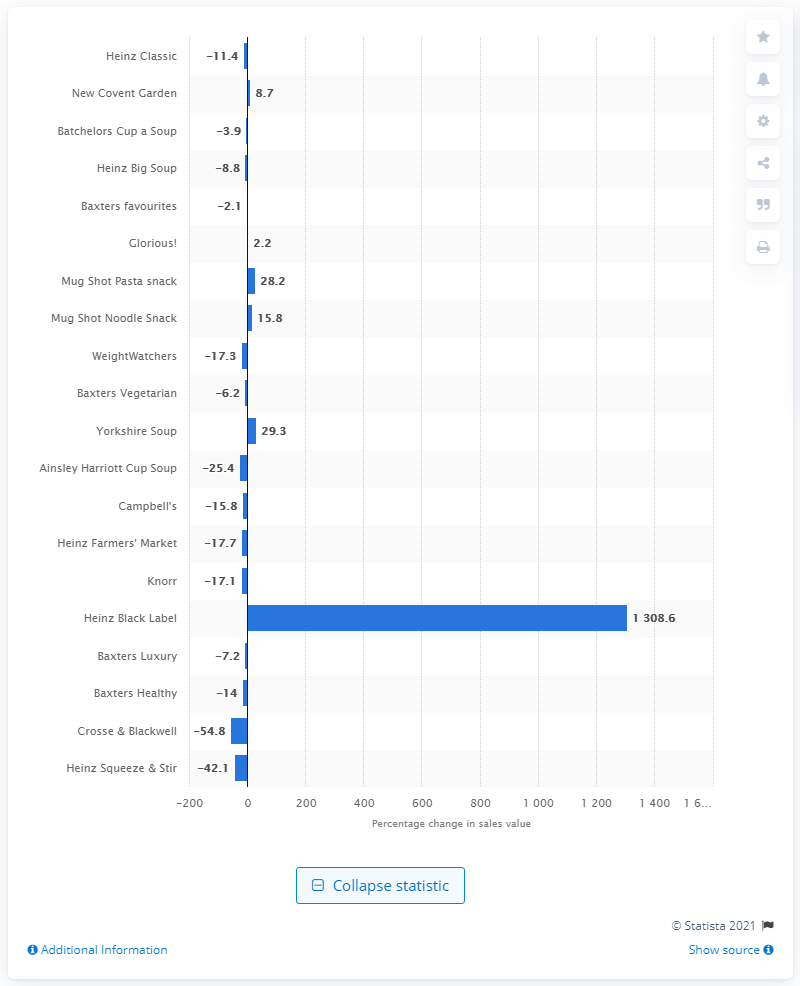Highlight a few significant elements in this photo. In 2013, the sales of Heinz Black Label products increased by 1308.6%. 